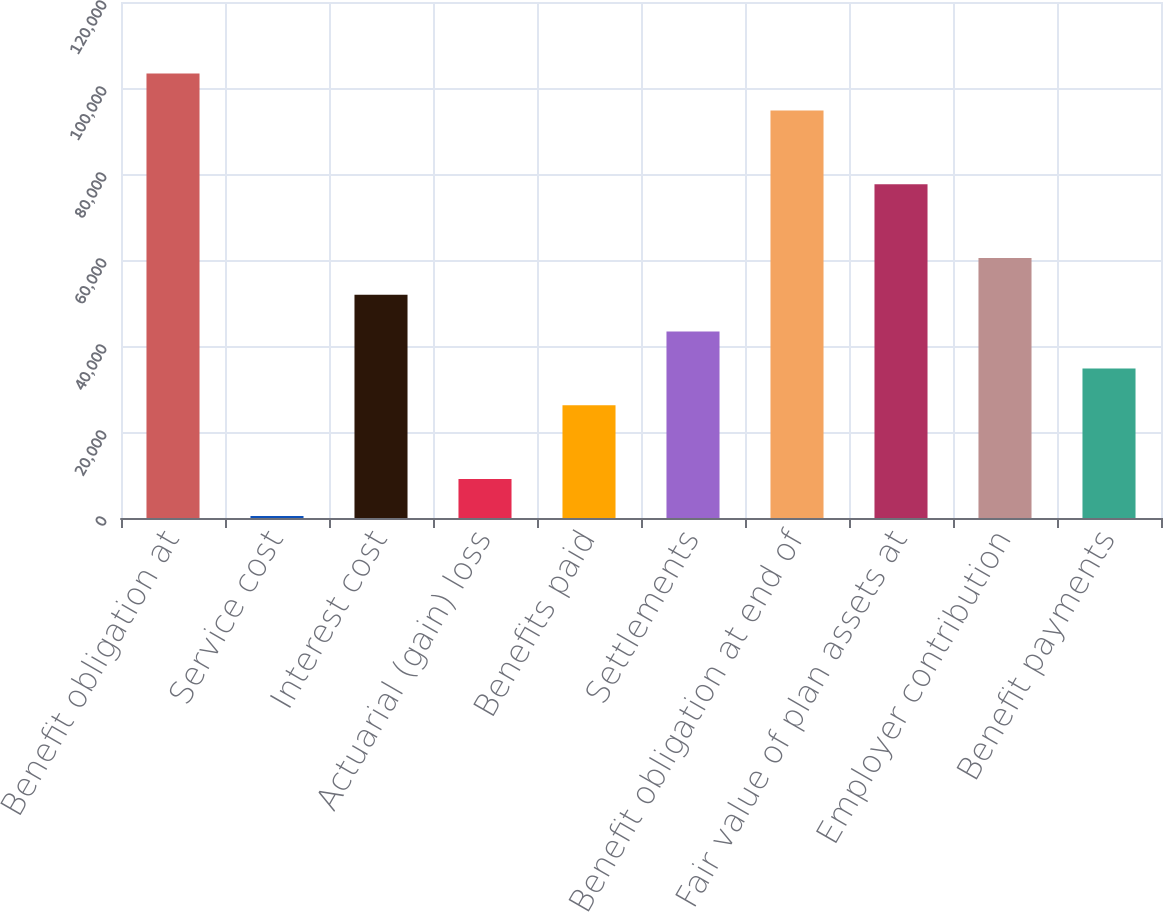Convert chart. <chart><loc_0><loc_0><loc_500><loc_500><bar_chart><fcel>Benefit obligation at<fcel>Service cost<fcel>Interest cost<fcel>Actuarial (gain) loss<fcel>Benefits paid<fcel>Settlements<fcel>Benefit obligation at end of<fcel>Fair value of plan assets at<fcel>Employer contribution<fcel>Benefit payments<nl><fcel>103349<fcel>487<fcel>51917.8<fcel>9058.8<fcel>26202.4<fcel>43346<fcel>94776.8<fcel>77633.2<fcel>60489.6<fcel>34774.2<nl></chart> 